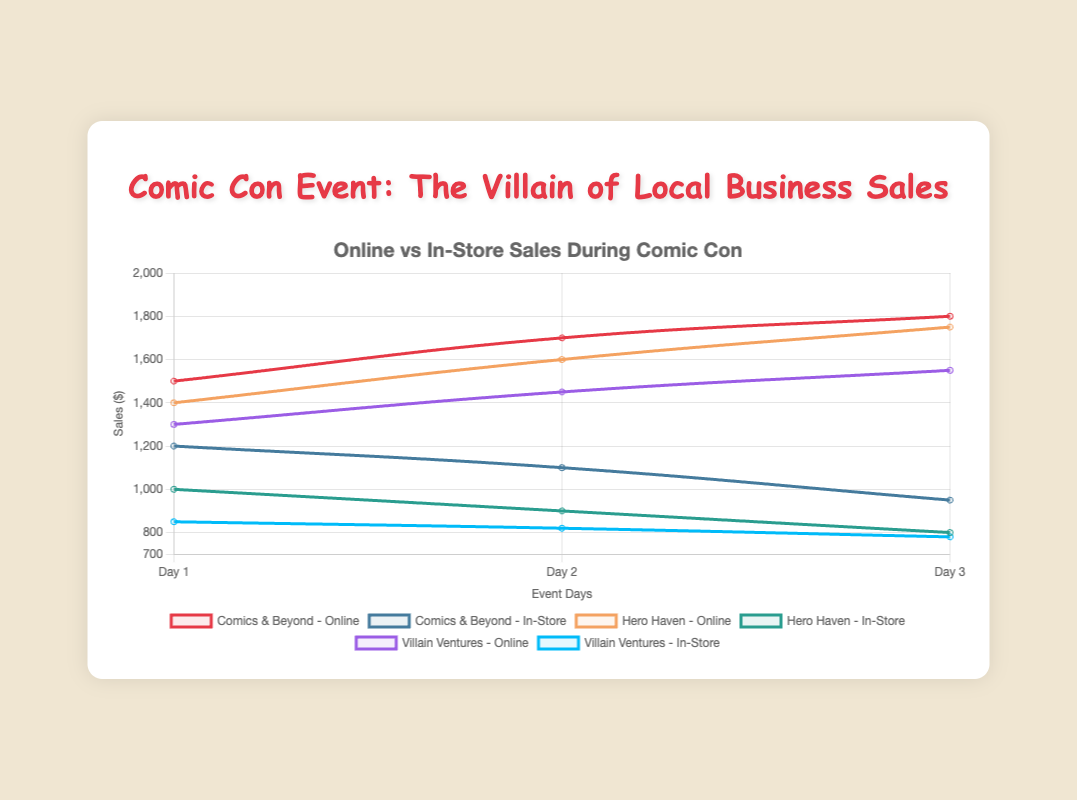How did online sales for "Comics & Beyond" change from Day 1 to Day 2? To determine the change in online sales for "Comics & Beyond" between Day 1 and Day 2, subtract the Day 1 sales from the Day 2 sales: 1700 - 1500 = 200.
Answer: Increased by 200 Which business had the highest in-store sales on Day 1? Compare the in-store sales for each business on Day 1. "Comics & Beyond" had 1200, "Hero Haven" had 1000, and "Villain Ventures" had 850. The highest value is 1200.
Answer: Comics & Beyond What is the average online sales for "Hero Haven" across the 3 days? Sum the online sales for "Hero Haven" over the three days: 1400 + 1600 + 1750 = 4750. Then divide by 3: 4750 / 3 ≈ 1583.33.
Answer: 1583.33 On which day did "Villain Ventures" experience its lowest in-store sales? Review the in-store sales for "Villain Ventures" over the three days. Day 1: 850, Day 2: 820, Day 3: 780. The lowest value is on Day 3.
Answer: Day 3 Compare the difference in in-store sales between "Comics & Beyond" and "Hero Haven" on Day 2. Subtract the in-store sales of "Hero Haven" from that of "Comics & Beyond" on Day 2: 1100 - 900 = 200.
Answer: 200 What is the trend of online sales for "Villain Ventures" over the 3 days? Visually inspect the online sales values for "Villain Ventures" across the 3 days: Day 1: 1300, Day 2: 1450, Day 3: 1550. The trend shows a steady increase each day.
Answer: Increasing Which business had the largest drop in in-store sales from Day 1 to Day 3? Calculate the drop for each business: "Comics & Beyond" (1200 - 950 = 250), "Hero Haven" (1000 - 800 = 200), "Villain Ventures" (850 - 780 = 70). The largest drop is for "Comics & Beyond".
Answer: Comics & Beyond On Day 3, which business had the closest online sales to 1500? Check the online sales for each business on Day 3: "Comics & Beyond" 1800, "Hero Haven" 1750, "Villain Ventures" 1550. The closest value to 1500 is 1550.
Answer: Villain Ventures Compare the online sales of "Comics & Beyond" and "Hero Haven" on Day 3. Which was higher and by how much? Subtract "Hero Haven"'s online sales from "Comics & Beyond"'s on Day 3: 1800 - 1750 = 50.
Answer: Comics & Beyond by 50 What is the average in-store sales for "Villain Ventures" across all event days? Sum the in-store sales for "Villain Ventures" over the three days: 850 + 820 + 780 = 2450. Then divide by 3: 2450 / 3 ≈ 816.67.
Answer: 816.67 